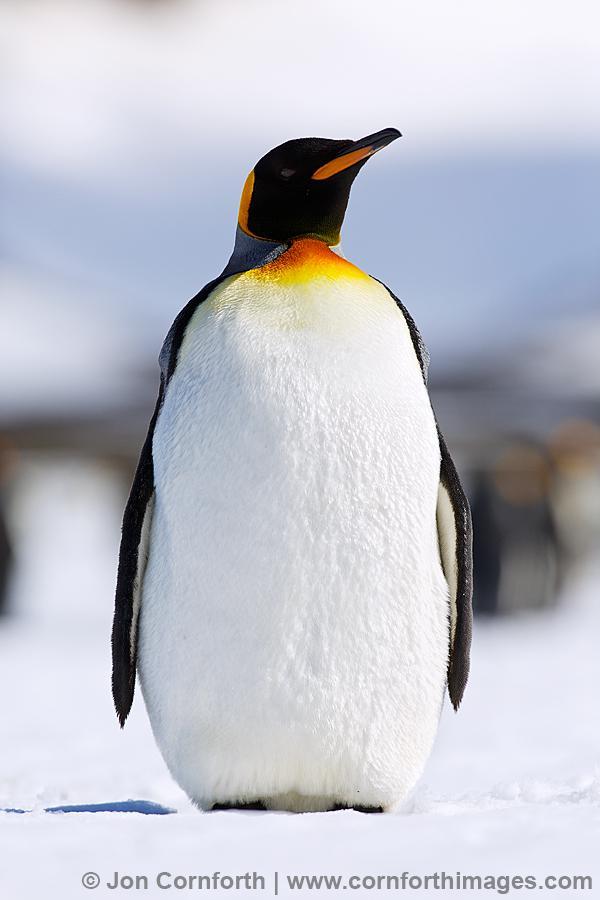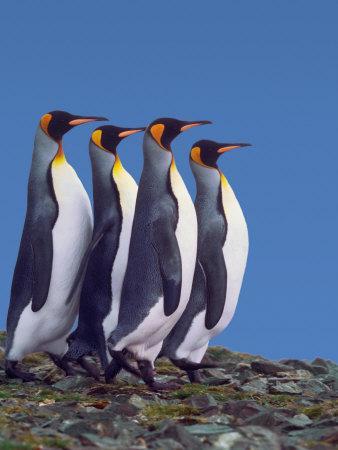The first image is the image on the left, the second image is the image on the right. Evaluate the accuracy of this statement regarding the images: "There are two adult penguins standing with a baby penguin in the image on the right.". Is it true? Answer yes or no. No. 